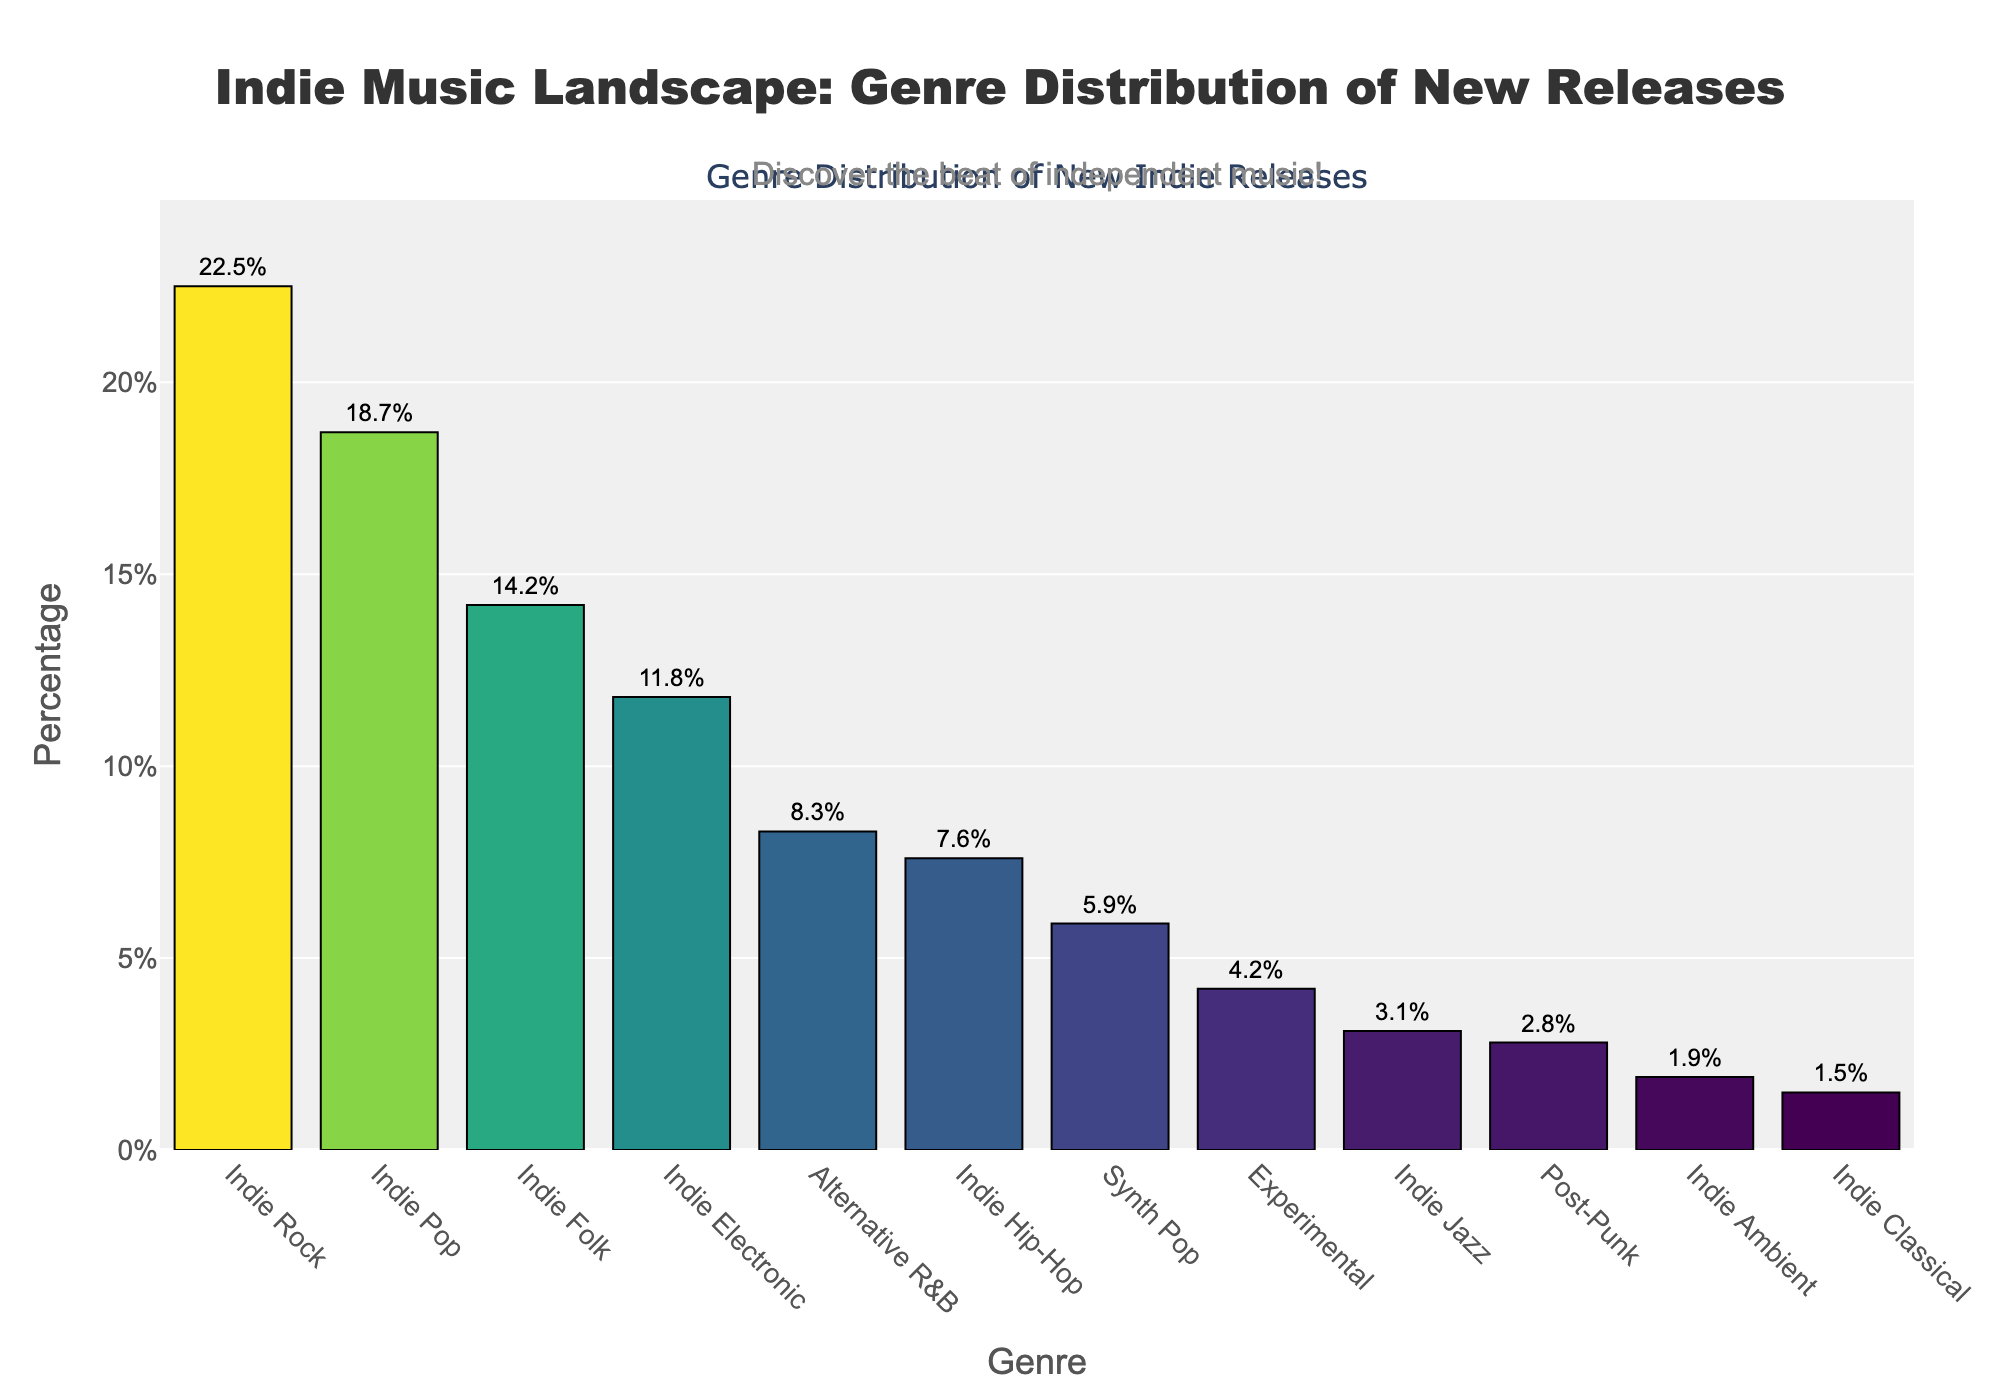What genre has the highest percentage of new indie releases? The genre with the highest bar and percentage label is Indie Rock at 22.5%.
Answer: Indie Rock Which genre has a higher percentage of new releases, Indie Folk or Alternative R&B? Comparing the height and percentage labels, Indie Folk has 14.2% while Alternative R&B has 8.3%.
Answer: Indie Folk Which genre has the lowest percentage of new indie releases? The genre with the shortest bar and lowest percentage label is Indie Classical at 1.5%.
Answer: Indie Classical How does the percentage of Indie Pop releases compare to Indie Electronic releases? Indie Pop has a percentage of 18.7% whereas Indie Electronic has 11.8%. Since 18.7% is greater than 11.8%, Indie Pop has a higher percentage.
Answer: Indie Pop Add up the percentages of Indie Hip-Hop and Synth Pop. What is the total? Indie Hip-Hop has 7.6% and Synth Pop has 5.9%. Adding these together: 7.6 + 5.9 = 13.5%.
Answer: 13.5% What is the combined percentage of the three smallest genres? The three smallest genres are Indie Ambient (1.9%), Indie Classical (1.5%), and Post-Punk (2.8%). Adding these together: 1.9 + 1.5 + 2.8 = 6.2%.
Answer: 6.2% Which genre has the most moderate percentage around the average of all genres? To find the average, sum all percentages (22.5+18.7+14.2+11.8+8.3+7.6+5.9+4.2+3.1+2.8+1.9+1.5=102.5) and divide by the number of genres (12): 102.5 / 12 ≈ 8.54%. The closest genre to this average is Alternative R&B at 8.3%.
Answer: Alternative R&B What is the difference in percentage between the highest and lowest genres? Indie Rock has the highest percentage at 22.5% and Indie Classical the lowest at 1.5%. The difference is 22.5 - 1.5 = 21%.
Answer: 21% 